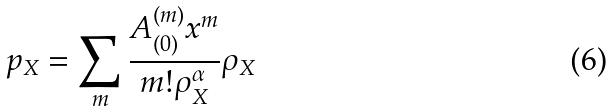Convert formula to latex. <formula><loc_0><loc_0><loc_500><loc_500>p _ { X } = \sum _ { m } \frac { A _ { ( 0 ) } ^ { ( m ) } x ^ { m } } { m ! \rho _ { X } ^ { \alpha } } \rho _ { X }</formula> 